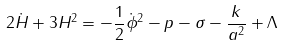Convert formula to latex. <formula><loc_0><loc_0><loc_500><loc_500>2 \dot { H } + 3 H ^ { 2 } = - \frac { 1 } { 2 } \dot { \phi } ^ { 2 } - p - \sigma - \frac { k } { a ^ { 2 } } + \Lambda</formula> 